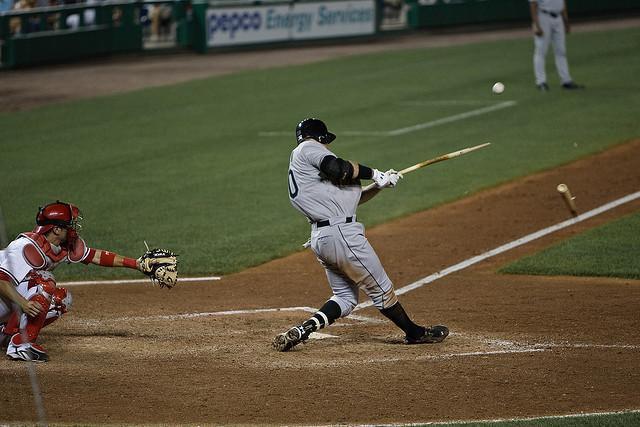How many people can you see?
Give a very brief answer. 3. 